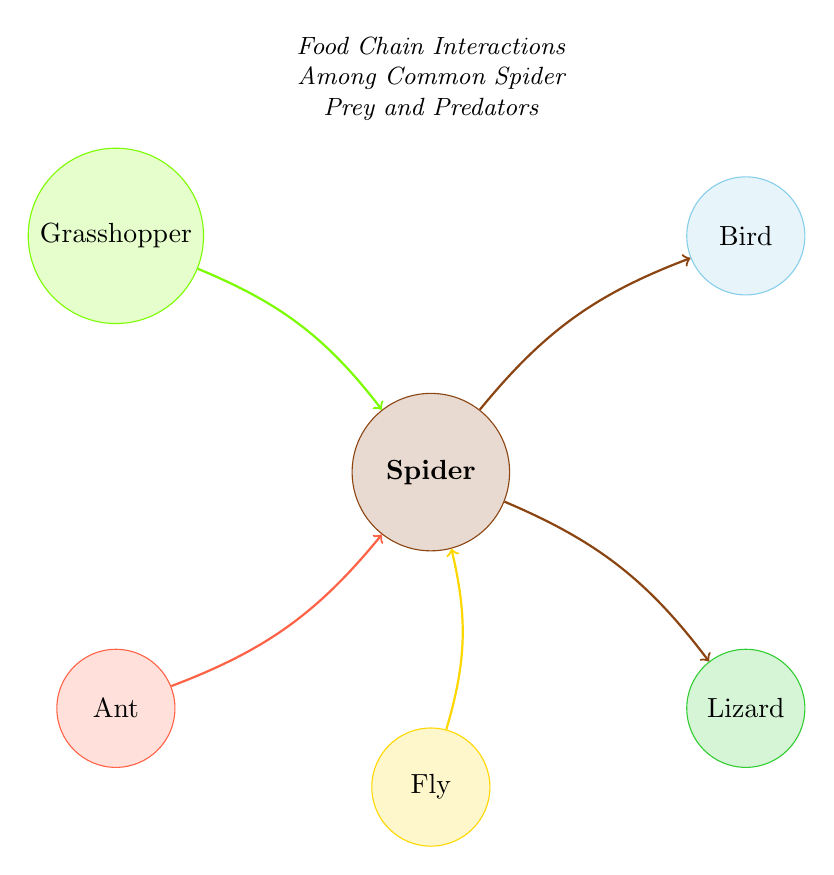What is the total number of nodes in the diagram? The diagram shows six distinct nodes: Grasshopper, Spider, Bird, Ant, Fly, and Lizard. By counting each unique node, we find the total is six.
Answer: 6 Which creature is a predator of the Spider? In the diagram, both the Bird and the Lizard have arrows pointing toward them from the Spider, indicating that they are predators of the Spider. Thus, the answer is either Bird or Lizard.
Answer: Bird, Lizard How many different prey does the Spider have? The diagram illustrates that the Spider is connected with three arrows coming from Grasshopper, Fly, and Ant. Therefore, the Spider has three different prey.
Answer: 3 Which node has the most outgoing links? The Spider node has two outgoing links going toward the Bird and the Lizard. No other node has outgoing links; thus, the Spider has the most outgoing links.
Answer: Spider Is there a direct link from Ant to Bird? The diagram shows no arrows or links connecting Ant directly to Bird, indicating that there is no direct relationship between these two nodes.
Answer: No 